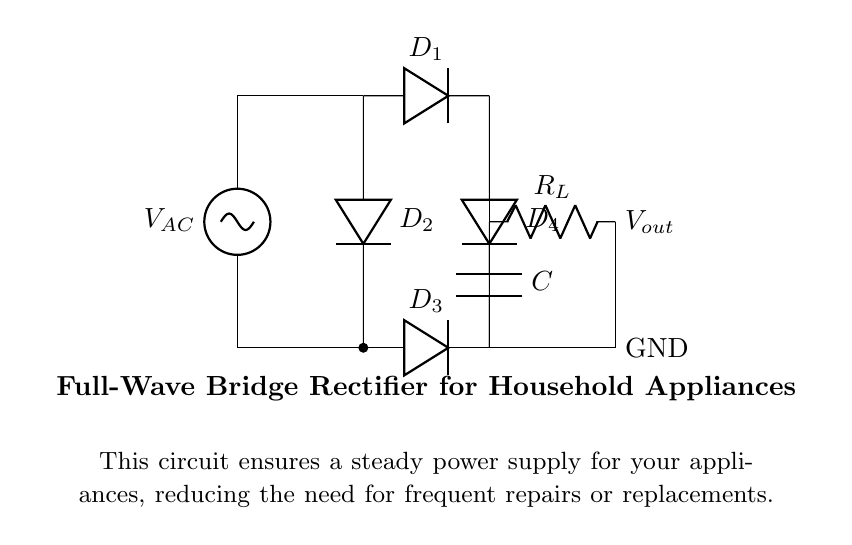What is the type of rectifier shown in the diagram? The diagram depicts a full-wave bridge rectifier, which utilizes four diodes arranged in a bridge configuration to convert AC voltage to DC voltage.
Answer: full-wave bridge rectifier How many diodes are in this circuit? The circuit contains four diodes, labeled as D1, D2, D3, and D4. Each diode contributes to converting the AC input into a usable DC output.
Answer: four What is the purpose of the capacitor in this circuit? The capacitor (C) smooths out the rectified voltage by filtering the ripples, providing a more stable DC supply for household appliances. This stabilization is crucial for consistent appliance performance.
Answer: smooth voltage What does R_L represent in this circuit? R_L is the load resistor, which represents the appliance or device that consumes the rectified power. It is necessary for the circuit to function in a household setting, as it provides a path for current flow.
Answer: load resistor How does this rectifier improve power reliability for appliances? The full-wave bridge rectifier allows for both halves of the AC waveform to contribute to the output, effectively doubling the frequency of the pulsed DC signal, resulting in better efficiency and reduced ripple voltage. This leads to fewer disruptions and longer appliance life.
Answer: improves reliability What are the input and output connections in this circuit? The input connections involve the AC voltage source at the top (V_AC), while the output is taken across the load resistor R_L on the right side, providing the usable DC voltage for appliances.
Answer: AC and DC connections What would happen if one diode in the bridge rectifier fails? If one diode fails, it could lead to reduced efficiency or complete failure of the rectification process, causing the output voltage to drop significantly and potentially damaging connected appliances due to unsteady power supply.
Answer: reduced efficiency 